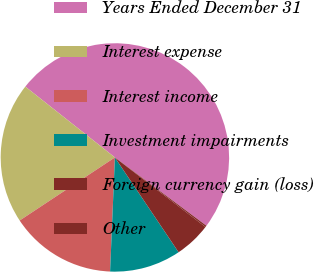<chart> <loc_0><loc_0><loc_500><loc_500><pie_chart><fcel>Years Ended December 31<fcel>Interest expense<fcel>Interest income<fcel>Investment impairments<fcel>Foreign currency gain (loss)<fcel>Other<nl><fcel>49.56%<fcel>19.96%<fcel>15.02%<fcel>10.09%<fcel>5.16%<fcel>0.22%<nl></chart> 